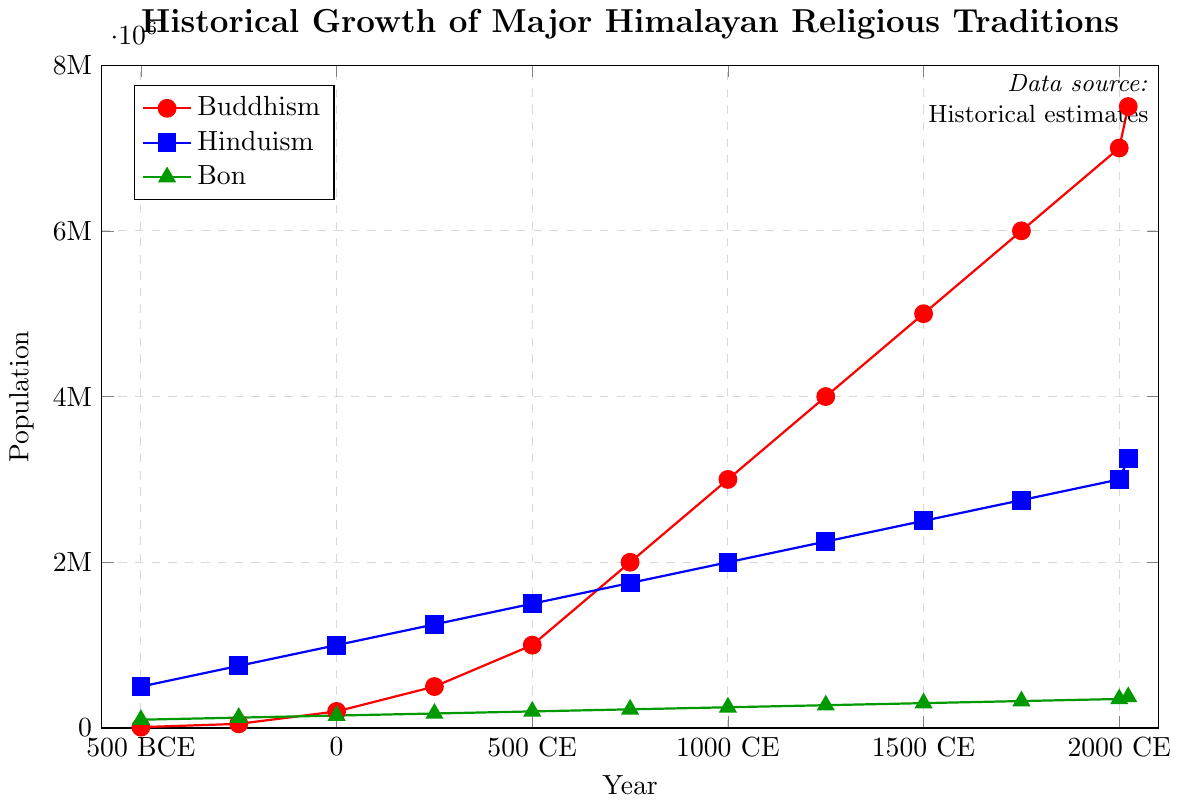What is the population of Buddhism around the year 0? From the chart, locate the year 0 on the x-axis and follow it upwards until it intersects with the red line representing Buddhism. The corresponding y-value is the population.
Answer: 200000 Which religion shows the highest population growth from 500 BCE to 2023? Compare the initial and final populations of Buddhism, Hinduism, and Bon according to the chart. The differences are: Buddhism (7500000-10000 = 7490000), Hinduism (3250000-500000 = 2750000), and Bon (375000-100000 = 275000). Buddhism exhibits the highest growth.
Answer: Buddhism How does the population growth of Hinduism between 1000 CE and 1500 CE compare to Buddhism in the same period? For Hinduism, subtract the population at 1000 CE from the population at 1500 CE, which is 2500000-2000000 = 500000. For Buddhism, it is 5000000-3000000 = 2000000. Buddhism's growth is higher during this period.
Answer: Buddhism's growth is higher What is the total population of all three religions in the year 2000? Sum the populations of Buddhism, Hinduism, and Bon for the year 2000: 7000000 (Buddhism) + 3000000 (Hinduism) + 350000 (Bon) = 10350000.
Answer: 10350000 Which religion has the smallest population growth rate between 1000 CE and 2023? Calculate the population growth rates: Buddhism (7500000-3000000), Hinduism (3250000-2000000), and Bon (375000-250000). The smallest difference is for Bon (125000), making it the smallest growth rate.
Answer: Bon What can you say about the relative populations of Buddhism and Bon in 500 CE? Locate the year 500 on the x-axis and compare the populations of Buddhism and Bon. Buddhism is depicted higher than Bon at 1000000 compared to Bon's 200000.
Answer: Buddhism is significantly higher Estimate the average population of Hinduism every 500 years from 0 to 2000. List Hinduism's populations at 0, 500, 1000, 1500, and 2000 CE: 1000000, 1500000, 2000000, 2500000, and 3000000. Calculate the average: (1000000 + 1500000 + 2000000 + 2500000 + 3000000) / 5 = 2000000.
Answer: 2000000 Compare the population growth rates of Buddhism and Bon from 500 BCE to 500 CE. Which grew faster? For Buddhism: (1000000 - 10000) over 1000 years, giving a rate of 990000/1000 = 990/year. For Bon: (200000 - 100000) over 1000 years, giving a rate of 100000/1000 = 100/year. Buddhism grew faster.
Answer: Buddhism What year does Hinduism surpass a population of 2500000? Trace Hinduism's growth on the chart until it reaches 2500000 on the y-axis, corresponding to the year 1500 CE.
Answer: 1500 CE In which interval does Bon experience the least population growth? Evaluate the changes over each interval. Bon's populations: 100000, 125000, 150000, 175000, 200000, 225000, 250000, 275000, 300000, 325000, 350000, 375000. The smallest change is (225000-200000) between 750 CE and 1000 CE.
Answer: 750 CE to 1000 CE 